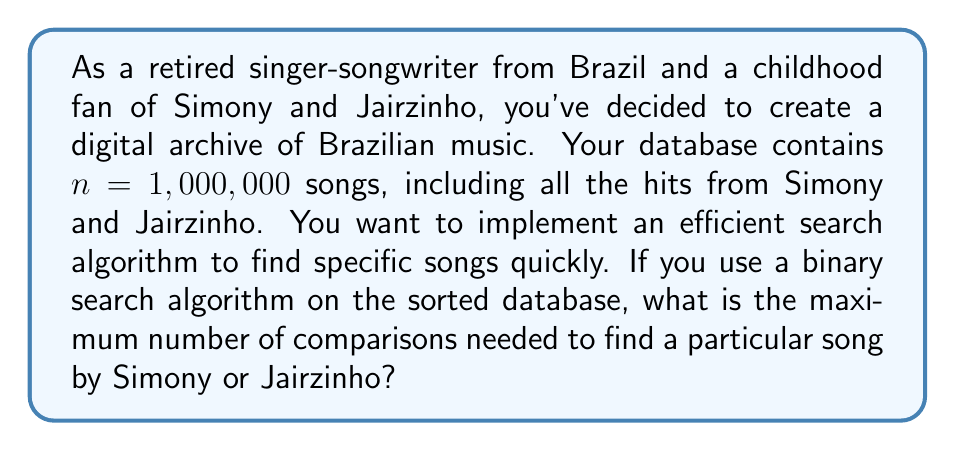Show me your answer to this math problem. To solve this problem, we need to understand the efficiency of the binary search algorithm:

1. Binary search works on sorted data by repeatedly dividing the search interval in half.

2. The worst-case time complexity of binary search is $O(\log_2 n)$, where $n$ is the number of elements in the sorted list.

3. The maximum number of comparisons in binary search is equal to $\lfloor \log_2 n \rfloor + 1$, where $\lfloor \cdot \rfloor$ denotes the floor function.

4. In this case, $n = 1,000,000$ songs.

5. Let's calculate:

   $$\lfloor \log_2 1,000,000 \rfloor + 1$$

6. $\log_2 1,000,000 \approx 19.9315685693$

7. $\lfloor 19.9315685693 \rfloor = 19$

8. Therefore, the maximum number of comparisons is:

   $$19 + 1 = 20$$

This means that in the worst-case scenario, it would take at most 20 comparisons to find any song by Simony or Jairzinho (or any other artist) in your database of 1 million songs using binary search.
Answer: 20 comparisons 